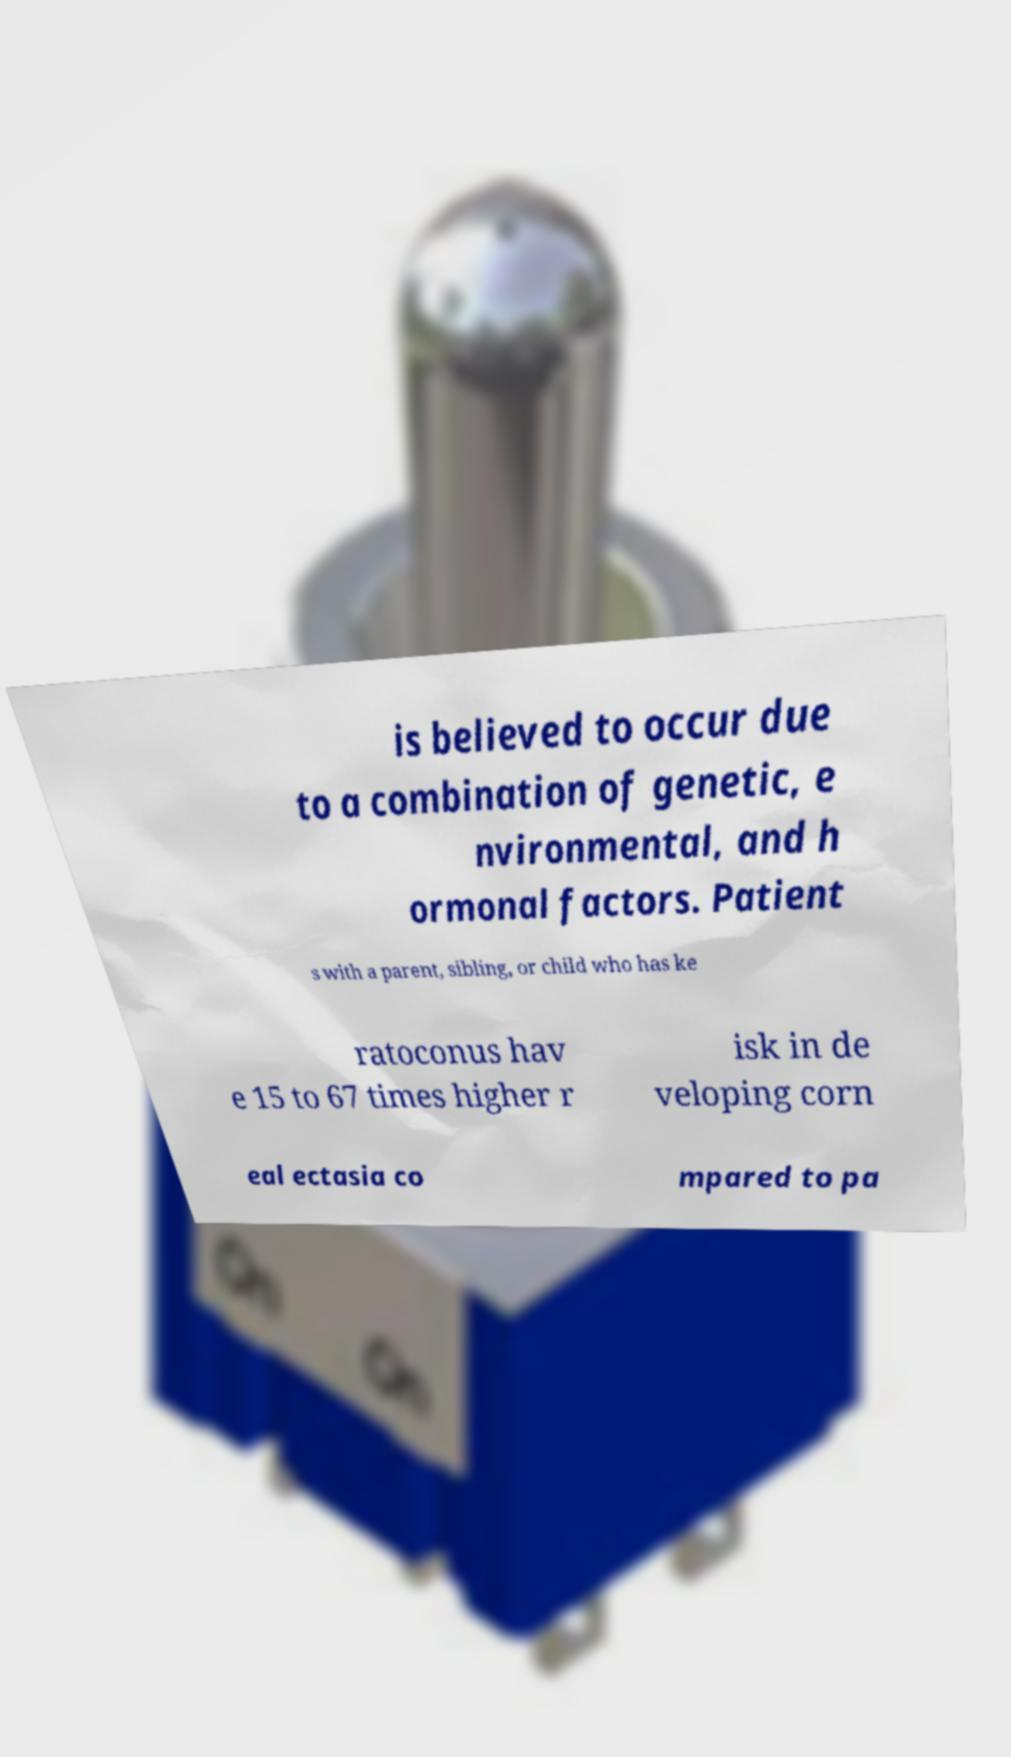Could you assist in decoding the text presented in this image and type it out clearly? is believed to occur due to a combination of genetic, e nvironmental, and h ormonal factors. Patient s with a parent, sibling, or child who has ke ratoconus hav e 15 to 67 times higher r isk in de veloping corn eal ectasia co mpared to pa 